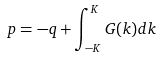<formula> <loc_0><loc_0><loc_500><loc_500>p = - q + \int _ { - K } ^ { K } G ( k ) d k</formula> 